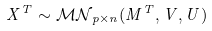Convert formula to latex. <formula><loc_0><loc_0><loc_500><loc_500>X ^ { T } \sim { \mathcal { M N } } _ { p \times n } ( M ^ { T } , V , U )</formula> 